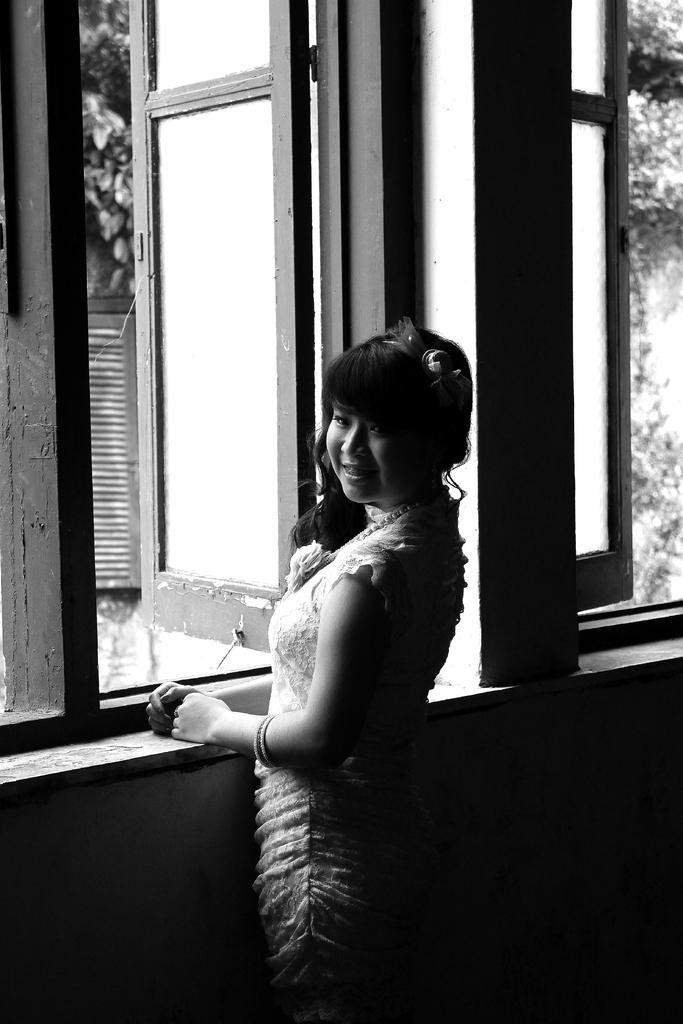Describe this image in one or two sentences. In this image I see a woman who is standing over here and I see that she is smiling and I see the windows and I see that this is a black and white image and it is dark over here. 